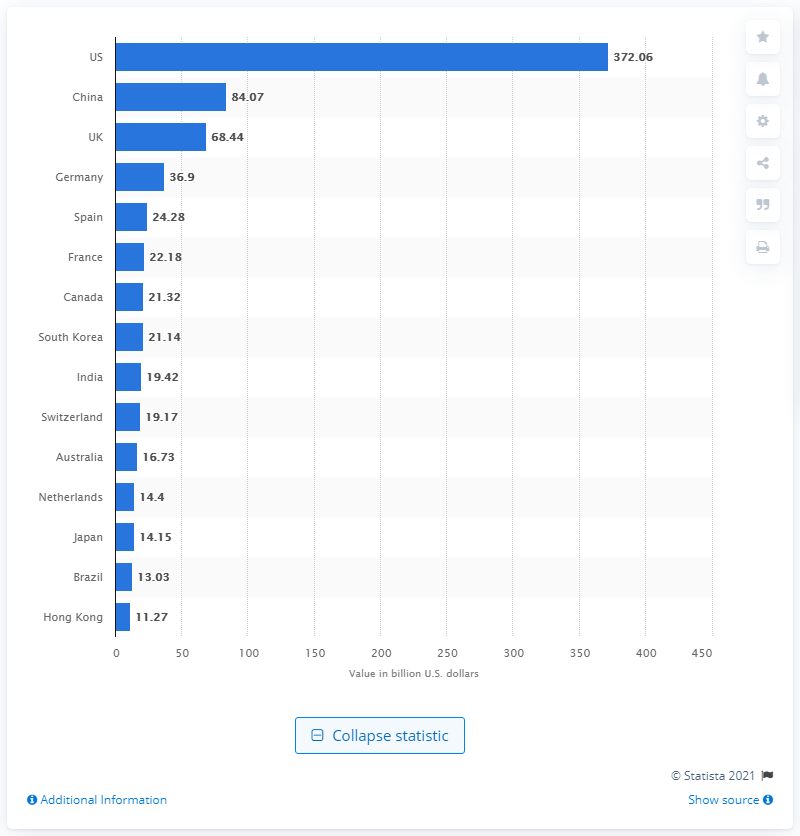Highlight a few significant elements in this photo. In 2019, the value of private equity deals in the United States was approximately 372.06. 